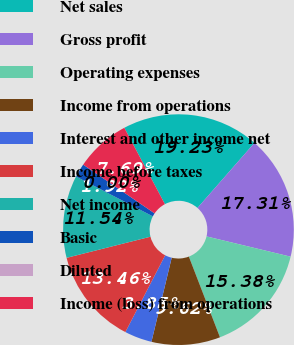<chart> <loc_0><loc_0><loc_500><loc_500><pie_chart><fcel>Net sales<fcel>Gross profit<fcel>Operating expenses<fcel>Income from operations<fcel>Interest and other income net<fcel>Income before taxes<fcel>Net income<fcel>Basic<fcel>Diluted<fcel>Income (loss) from operations<nl><fcel>19.23%<fcel>17.31%<fcel>15.38%<fcel>9.62%<fcel>3.85%<fcel>13.46%<fcel>11.54%<fcel>1.92%<fcel>0.0%<fcel>7.69%<nl></chart> 